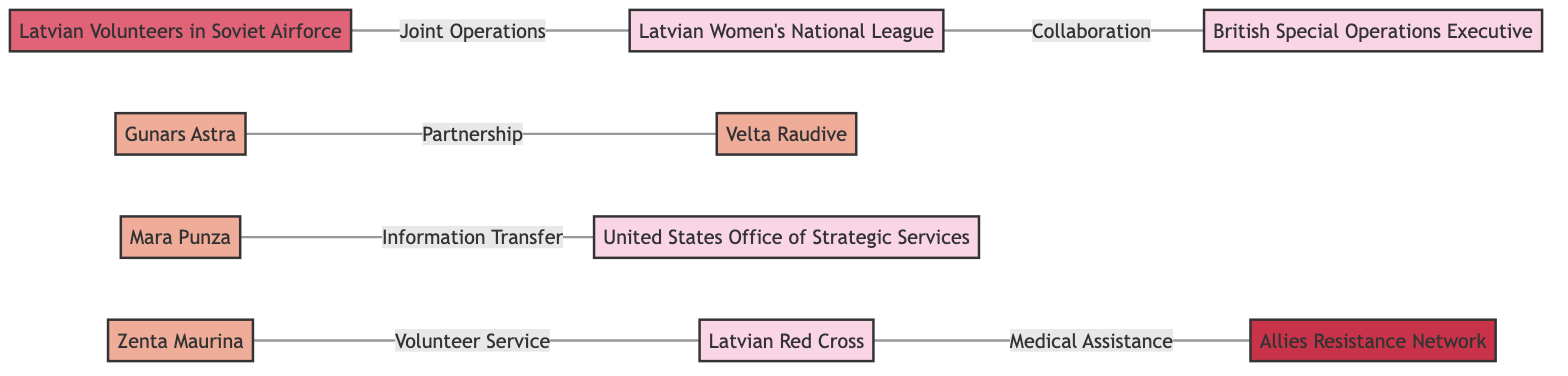What is the label of the organization connected to Latvian Women's National League? The organization connected to the Latvian Women's National League is labeled "British Special Operations Executive", as indicated by the direct link between the two in the diagram.
Answer: British Special Operations Executive How many individual nodes are present in the diagram? There are five individual nodes: Mara Punza, Gunars Astra, Velta Raudive, Zenta Maurina, and Latvian Women National League. Counting each of these nodes gives a total of five.
Answer: 5 Which group collaborates with the Latvian Women's National League? The group collaborating with the Latvian Women's National League is the "Latvian Volunteers in Soviet Airforce," as shown by the edge connecting both nodes labeled "Joint Operations."
Answer: Latvian Volunteers in Soviet Airforce Who provides medical assistance to the Allies Resistance Network? The "Latvian Red Cross" provides medical assistance to the Allies Resistance Network, as depicted by the edge connecting these two nodes labeled "Medical Assistance."
Answer: Latvian Red Cross How many total connections (edges) are there in the diagram? There are six connections (edges) in the diagram from the listed relationships among the nodes. Counting the edges results in a total of six.
Answer: 6 What type of relationship exists between Gunars Astra and Velta Raudive? The relationship between Gunars Astra and Velta Raudive is labeled "Partnership," which indicates a collaborative link between these two individuals in the diagram.
Answer: Partnership Which organization is associated with Mara Punza? Mara Punza is associated with the "United States Office of Strategic Services," as the edge labeled "Information Transfer" connects her to this organization in the diagram.
Answer: United States Office of Strategic Services Identify the individual who volunteers for the Latvian Red Cross. The individual who volunteers for the Latvian Red Cross is "Zenta Maurina," as shown by the connection labeled "Volunteer Service" linking her to the Latvian Red Cross.
Answer: Zenta Maurina What type of node is the Allies Resistance Network? The Allies Resistance Network is classified as a "Network" node, as denoted by its specific label in the diagram which highlights its categorization.
Answer: Network 